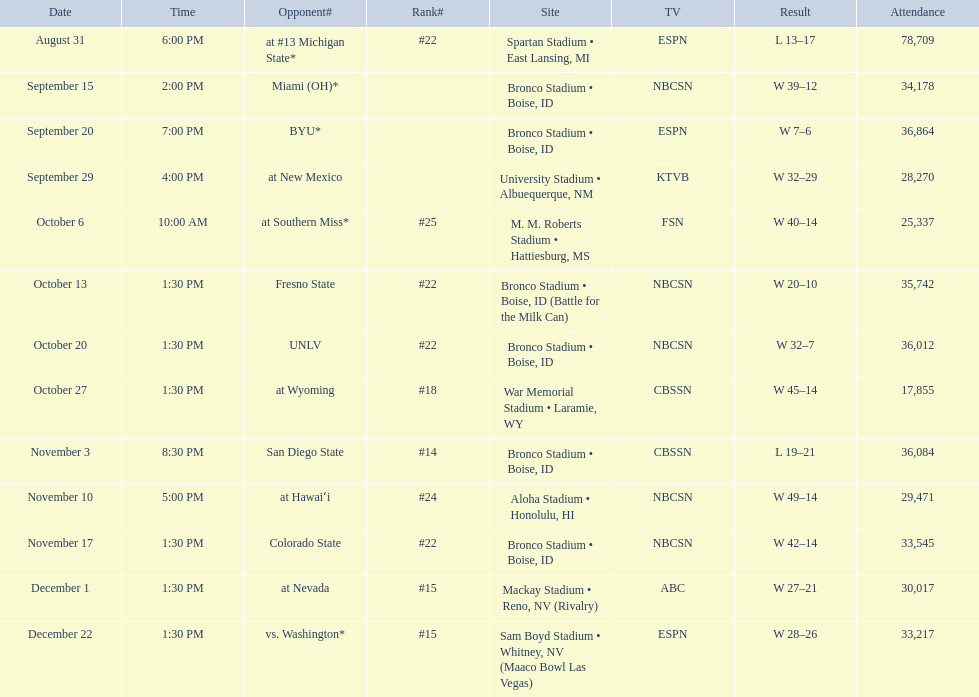What was the most consecutive wins for the team shown in the season? 7. 